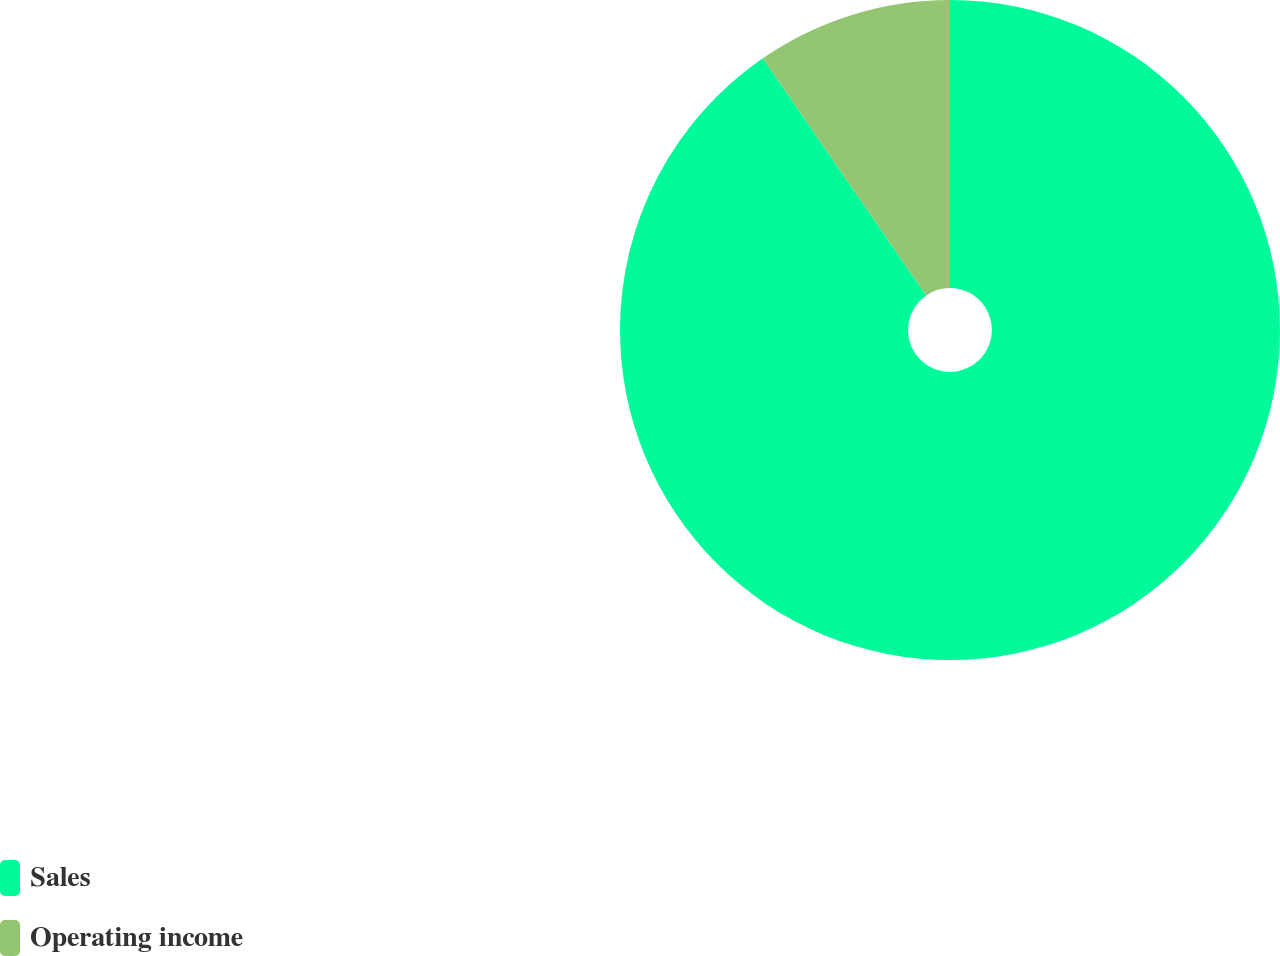<chart> <loc_0><loc_0><loc_500><loc_500><pie_chart><fcel>Sales<fcel>Operating income<nl><fcel>90.4%<fcel>9.6%<nl></chart> 